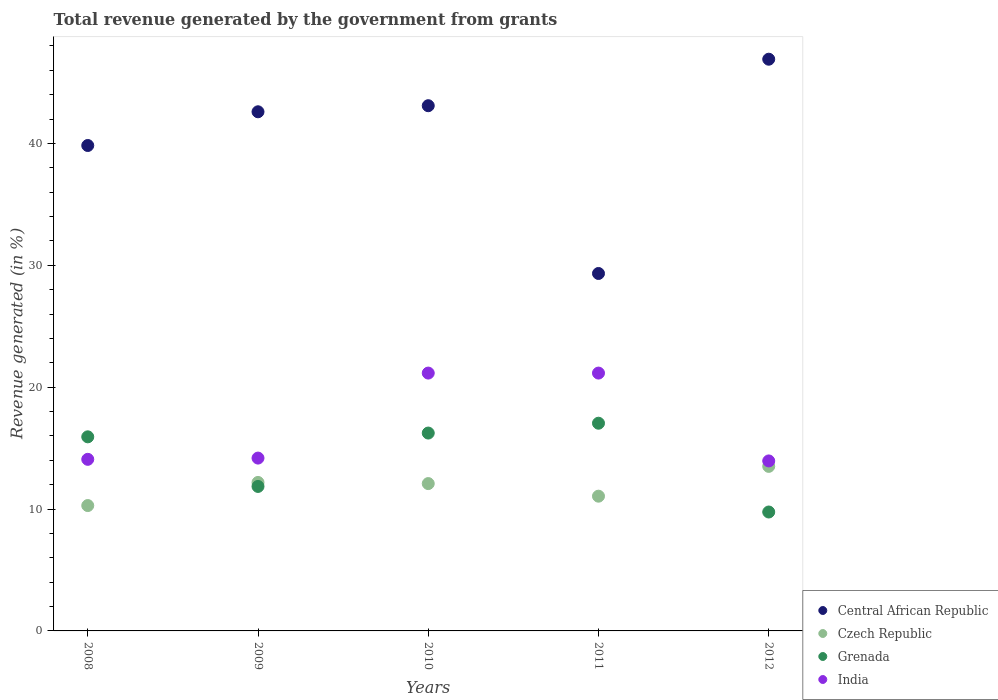How many different coloured dotlines are there?
Your answer should be compact. 4. What is the total revenue generated in India in 2009?
Offer a very short reply. 14.18. Across all years, what is the maximum total revenue generated in India?
Provide a succinct answer. 21.16. Across all years, what is the minimum total revenue generated in India?
Provide a short and direct response. 13.95. In which year was the total revenue generated in Central African Republic maximum?
Offer a terse response. 2012. In which year was the total revenue generated in Central African Republic minimum?
Provide a succinct answer. 2011. What is the total total revenue generated in Grenada in the graph?
Provide a succinct answer. 70.82. What is the difference between the total revenue generated in Czech Republic in 2008 and that in 2010?
Offer a terse response. -1.8. What is the difference between the total revenue generated in Czech Republic in 2008 and the total revenue generated in Central African Republic in 2012?
Offer a terse response. -36.63. What is the average total revenue generated in Grenada per year?
Give a very brief answer. 14.16. In the year 2008, what is the difference between the total revenue generated in Czech Republic and total revenue generated in Grenada?
Offer a terse response. -5.64. What is the ratio of the total revenue generated in Central African Republic in 2011 to that in 2012?
Your response must be concise. 0.63. Is the total revenue generated in Grenada in 2008 less than that in 2010?
Your answer should be compact. Yes. What is the difference between the highest and the lowest total revenue generated in Czech Republic?
Provide a short and direct response. 3.22. Is the sum of the total revenue generated in Central African Republic in 2008 and 2009 greater than the maximum total revenue generated in India across all years?
Your answer should be compact. Yes. Is the total revenue generated in India strictly greater than the total revenue generated in Czech Republic over the years?
Ensure brevity in your answer.  Yes. How many years are there in the graph?
Your answer should be compact. 5. Are the values on the major ticks of Y-axis written in scientific E-notation?
Keep it short and to the point. No. Does the graph contain any zero values?
Ensure brevity in your answer.  No. Does the graph contain grids?
Give a very brief answer. No. Where does the legend appear in the graph?
Provide a short and direct response. Bottom right. What is the title of the graph?
Provide a short and direct response. Total revenue generated by the government from grants. Does "St. Martin (French part)" appear as one of the legend labels in the graph?
Make the answer very short. No. What is the label or title of the Y-axis?
Your answer should be compact. Revenue generated (in %). What is the Revenue generated (in %) in Central African Republic in 2008?
Offer a terse response. 39.83. What is the Revenue generated (in %) of Czech Republic in 2008?
Offer a terse response. 10.29. What is the Revenue generated (in %) of Grenada in 2008?
Ensure brevity in your answer.  15.93. What is the Revenue generated (in %) of India in 2008?
Keep it short and to the point. 14.08. What is the Revenue generated (in %) in Central African Republic in 2009?
Your answer should be compact. 42.6. What is the Revenue generated (in %) of Czech Republic in 2009?
Give a very brief answer. 12.18. What is the Revenue generated (in %) in Grenada in 2009?
Ensure brevity in your answer.  11.86. What is the Revenue generated (in %) of India in 2009?
Give a very brief answer. 14.18. What is the Revenue generated (in %) of Central African Republic in 2010?
Your answer should be very brief. 43.1. What is the Revenue generated (in %) of Czech Republic in 2010?
Keep it short and to the point. 12.09. What is the Revenue generated (in %) of Grenada in 2010?
Your answer should be compact. 16.24. What is the Revenue generated (in %) of India in 2010?
Make the answer very short. 21.16. What is the Revenue generated (in %) in Central African Republic in 2011?
Offer a terse response. 29.33. What is the Revenue generated (in %) of Czech Republic in 2011?
Make the answer very short. 11.06. What is the Revenue generated (in %) in Grenada in 2011?
Offer a very short reply. 17.04. What is the Revenue generated (in %) of India in 2011?
Your answer should be compact. 21.16. What is the Revenue generated (in %) in Central African Republic in 2012?
Your answer should be very brief. 46.91. What is the Revenue generated (in %) of Czech Republic in 2012?
Provide a succinct answer. 13.5. What is the Revenue generated (in %) of Grenada in 2012?
Ensure brevity in your answer.  9.76. What is the Revenue generated (in %) in India in 2012?
Provide a succinct answer. 13.95. Across all years, what is the maximum Revenue generated (in %) in Central African Republic?
Your answer should be very brief. 46.91. Across all years, what is the maximum Revenue generated (in %) in Czech Republic?
Provide a succinct answer. 13.5. Across all years, what is the maximum Revenue generated (in %) in Grenada?
Offer a very short reply. 17.04. Across all years, what is the maximum Revenue generated (in %) in India?
Your answer should be compact. 21.16. Across all years, what is the minimum Revenue generated (in %) in Central African Republic?
Ensure brevity in your answer.  29.33. Across all years, what is the minimum Revenue generated (in %) of Czech Republic?
Offer a very short reply. 10.29. Across all years, what is the minimum Revenue generated (in %) in Grenada?
Your response must be concise. 9.76. Across all years, what is the minimum Revenue generated (in %) of India?
Your answer should be compact. 13.95. What is the total Revenue generated (in %) in Central African Republic in the graph?
Keep it short and to the point. 201.78. What is the total Revenue generated (in %) of Czech Republic in the graph?
Provide a succinct answer. 59.12. What is the total Revenue generated (in %) in Grenada in the graph?
Give a very brief answer. 70.82. What is the total Revenue generated (in %) in India in the graph?
Offer a very short reply. 84.53. What is the difference between the Revenue generated (in %) in Central African Republic in 2008 and that in 2009?
Your response must be concise. -2.77. What is the difference between the Revenue generated (in %) in Czech Republic in 2008 and that in 2009?
Keep it short and to the point. -1.9. What is the difference between the Revenue generated (in %) of Grenada in 2008 and that in 2009?
Provide a succinct answer. 4.07. What is the difference between the Revenue generated (in %) of India in 2008 and that in 2009?
Your answer should be very brief. -0.1. What is the difference between the Revenue generated (in %) of Central African Republic in 2008 and that in 2010?
Your response must be concise. -3.26. What is the difference between the Revenue generated (in %) in Czech Republic in 2008 and that in 2010?
Give a very brief answer. -1.8. What is the difference between the Revenue generated (in %) of Grenada in 2008 and that in 2010?
Offer a terse response. -0.31. What is the difference between the Revenue generated (in %) of India in 2008 and that in 2010?
Your answer should be compact. -7.08. What is the difference between the Revenue generated (in %) in Central African Republic in 2008 and that in 2011?
Make the answer very short. 10.5. What is the difference between the Revenue generated (in %) of Czech Republic in 2008 and that in 2011?
Offer a terse response. -0.77. What is the difference between the Revenue generated (in %) of Grenada in 2008 and that in 2011?
Your response must be concise. -1.12. What is the difference between the Revenue generated (in %) of India in 2008 and that in 2011?
Provide a short and direct response. -7.08. What is the difference between the Revenue generated (in %) of Central African Republic in 2008 and that in 2012?
Ensure brevity in your answer.  -7.08. What is the difference between the Revenue generated (in %) of Czech Republic in 2008 and that in 2012?
Ensure brevity in your answer.  -3.22. What is the difference between the Revenue generated (in %) in Grenada in 2008 and that in 2012?
Give a very brief answer. 6.17. What is the difference between the Revenue generated (in %) of India in 2008 and that in 2012?
Give a very brief answer. 0.13. What is the difference between the Revenue generated (in %) of Central African Republic in 2009 and that in 2010?
Your response must be concise. -0.5. What is the difference between the Revenue generated (in %) of Czech Republic in 2009 and that in 2010?
Your response must be concise. 0.09. What is the difference between the Revenue generated (in %) of Grenada in 2009 and that in 2010?
Ensure brevity in your answer.  -4.38. What is the difference between the Revenue generated (in %) of India in 2009 and that in 2010?
Keep it short and to the point. -6.98. What is the difference between the Revenue generated (in %) of Central African Republic in 2009 and that in 2011?
Your answer should be very brief. 13.27. What is the difference between the Revenue generated (in %) in Czech Republic in 2009 and that in 2011?
Offer a very short reply. 1.13. What is the difference between the Revenue generated (in %) in Grenada in 2009 and that in 2011?
Offer a very short reply. -5.19. What is the difference between the Revenue generated (in %) in India in 2009 and that in 2011?
Provide a short and direct response. -6.98. What is the difference between the Revenue generated (in %) of Central African Republic in 2009 and that in 2012?
Offer a terse response. -4.31. What is the difference between the Revenue generated (in %) of Czech Republic in 2009 and that in 2012?
Offer a very short reply. -1.32. What is the difference between the Revenue generated (in %) in Grenada in 2009 and that in 2012?
Provide a short and direct response. 2.1. What is the difference between the Revenue generated (in %) in India in 2009 and that in 2012?
Your answer should be very brief. 0.23. What is the difference between the Revenue generated (in %) of Central African Republic in 2010 and that in 2011?
Make the answer very short. 13.77. What is the difference between the Revenue generated (in %) in Czech Republic in 2010 and that in 2011?
Your response must be concise. 1.03. What is the difference between the Revenue generated (in %) of Grenada in 2010 and that in 2011?
Make the answer very short. -0.81. What is the difference between the Revenue generated (in %) of Central African Republic in 2010 and that in 2012?
Offer a terse response. -3.82. What is the difference between the Revenue generated (in %) of Czech Republic in 2010 and that in 2012?
Offer a terse response. -1.41. What is the difference between the Revenue generated (in %) in Grenada in 2010 and that in 2012?
Your answer should be compact. 6.48. What is the difference between the Revenue generated (in %) of India in 2010 and that in 2012?
Your response must be concise. 7.21. What is the difference between the Revenue generated (in %) of Central African Republic in 2011 and that in 2012?
Provide a succinct answer. -17.58. What is the difference between the Revenue generated (in %) of Czech Republic in 2011 and that in 2012?
Give a very brief answer. -2.45. What is the difference between the Revenue generated (in %) of Grenada in 2011 and that in 2012?
Give a very brief answer. 7.29. What is the difference between the Revenue generated (in %) of India in 2011 and that in 2012?
Offer a terse response. 7.21. What is the difference between the Revenue generated (in %) in Central African Republic in 2008 and the Revenue generated (in %) in Czech Republic in 2009?
Your answer should be very brief. 27.65. What is the difference between the Revenue generated (in %) of Central African Republic in 2008 and the Revenue generated (in %) of Grenada in 2009?
Offer a very short reply. 27.98. What is the difference between the Revenue generated (in %) of Central African Republic in 2008 and the Revenue generated (in %) of India in 2009?
Keep it short and to the point. 25.65. What is the difference between the Revenue generated (in %) of Czech Republic in 2008 and the Revenue generated (in %) of Grenada in 2009?
Offer a very short reply. -1.57. What is the difference between the Revenue generated (in %) in Czech Republic in 2008 and the Revenue generated (in %) in India in 2009?
Offer a very short reply. -3.9. What is the difference between the Revenue generated (in %) of Grenada in 2008 and the Revenue generated (in %) of India in 2009?
Ensure brevity in your answer.  1.74. What is the difference between the Revenue generated (in %) of Central African Republic in 2008 and the Revenue generated (in %) of Czech Republic in 2010?
Provide a short and direct response. 27.74. What is the difference between the Revenue generated (in %) of Central African Republic in 2008 and the Revenue generated (in %) of Grenada in 2010?
Your response must be concise. 23.6. What is the difference between the Revenue generated (in %) in Central African Republic in 2008 and the Revenue generated (in %) in India in 2010?
Give a very brief answer. 18.68. What is the difference between the Revenue generated (in %) of Czech Republic in 2008 and the Revenue generated (in %) of Grenada in 2010?
Provide a succinct answer. -5.95. What is the difference between the Revenue generated (in %) in Czech Republic in 2008 and the Revenue generated (in %) in India in 2010?
Provide a short and direct response. -10.87. What is the difference between the Revenue generated (in %) of Grenada in 2008 and the Revenue generated (in %) of India in 2010?
Provide a short and direct response. -5.23. What is the difference between the Revenue generated (in %) in Central African Republic in 2008 and the Revenue generated (in %) in Czech Republic in 2011?
Give a very brief answer. 28.78. What is the difference between the Revenue generated (in %) in Central African Republic in 2008 and the Revenue generated (in %) in Grenada in 2011?
Offer a terse response. 22.79. What is the difference between the Revenue generated (in %) in Central African Republic in 2008 and the Revenue generated (in %) in India in 2011?
Give a very brief answer. 18.68. What is the difference between the Revenue generated (in %) of Czech Republic in 2008 and the Revenue generated (in %) of Grenada in 2011?
Offer a very short reply. -6.76. What is the difference between the Revenue generated (in %) in Czech Republic in 2008 and the Revenue generated (in %) in India in 2011?
Provide a succinct answer. -10.87. What is the difference between the Revenue generated (in %) in Grenada in 2008 and the Revenue generated (in %) in India in 2011?
Keep it short and to the point. -5.23. What is the difference between the Revenue generated (in %) in Central African Republic in 2008 and the Revenue generated (in %) in Czech Republic in 2012?
Your answer should be very brief. 26.33. What is the difference between the Revenue generated (in %) of Central African Republic in 2008 and the Revenue generated (in %) of Grenada in 2012?
Ensure brevity in your answer.  30.08. What is the difference between the Revenue generated (in %) in Central African Republic in 2008 and the Revenue generated (in %) in India in 2012?
Ensure brevity in your answer.  25.88. What is the difference between the Revenue generated (in %) in Czech Republic in 2008 and the Revenue generated (in %) in Grenada in 2012?
Keep it short and to the point. 0.53. What is the difference between the Revenue generated (in %) in Czech Republic in 2008 and the Revenue generated (in %) in India in 2012?
Ensure brevity in your answer.  -3.66. What is the difference between the Revenue generated (in %) of Grenada in 2008 and the Revenue generated (in %) of India in 2012?
Make the answer very short. 1.98. What is the difference between the Revenue generated (in %) in Central African Republic in 2009 and the Revenue generated (in %) in Czech Republic in 2010?
Your response must be concise. 30.51. What is the difference between the Revenue generated (in %) in Central African Republic in 2009 and the Revenue generated (in %) in Grenada in 2010?
Your answer should be compact. 26.36. What is the difference between the Revenue generated (in %) of Central African Republic in 2009 and the Revenue generated (in %) of India in 2010?
Your answer should be very brief. 21.44. What is the difference between the Revenue generated (in %) in Czech Republic in 2009 and the Revenue generated (in %) in Grenada in 2010?
Provide a succinct answer. -4.05. What is the difference between the Revenue generated (in %) in Czech Republic in 2009 and the Revenue generated (in %) in India in 2010?
Give a very brief answer. -8.97. What is the difference between the Revenue generated (in %) in Grenada in 2009 and the Revenue generated (in %) in India in 2010?
Ensure brevity in your answer.  -9.3. What is the difference between the Revenue generated (in %) of Central African Republic in 2009 and the Revenue generated (in %) of Czech Republic in 2011?
Offer a very short reply. 31.54. What is the difference between the Revenue generated (in %) of Central African Republic in 2009 and the Revenue generated (in %) of Grenada in 2011?
Your answer should be compact. 25.56. What is the difference between the Revenue generated (in %) of Central African Republic in 2009 and the Revenue generated (in %) of India in 2011?
Provide a short and direct response. 21.44. What is the difference between the Revenue generated (in %) of Czech Republic in 2009 and the Revenue generated (in %) of Grenada in 2011?
Keep it short and to the point. -4.86. What is the difference between the Revenue generated (in %) in Czech Republic in 2009 and the Revenue generated (in %) in India in 2011?
Your response must be concise. -8.97. What is the difference between the Revenue generated (in %) in Grenada in 2009 and the Revenue generated (in %) in India in 2011?
Offer a very short reply. -9.3. What is the difference between the Revenue generated (in %) in Central African Republic in 2009 and the Revenue generated (in %) in Czech Republic in 2012?
Keep it short and to the point. 29.1. What is the difference between the Revenue generated (in %) of Central African Republic in 2009 and the Revenue generated (in %) of Grenada in 2012?
Make the answer very short. 32.84. What is the difference between the Revenue generated (in %) in Central African Republic in 2009 and the Revenue generated (in %) in India in 2012?
Offer a terse response. 28.65. What is the difference between the Revenue generated (in %) in Czech Republic in 2009 and the Revenue generated (in %) in Grenada in 2012?
Ensure brevity in your answer.  2.43. What is the difference between the Revenue generated (in %) in Czech Republic in 2009 and the Revenue generated (in %) in India in 2012?
Provide a short and direct response. -1.77. What is the difference between the Revenue generated (in %) in Grenada in 2009 and the Revenue generated (in %) in India in 2012?
Provide a succinct answer. -2.09. What is the difference between the Revenue generated (in %) of Central African Republic in 2010 and the Revenue generated (in %) of Czech Republic in 2011?
Give a very brief answer. 32.04. What is the difference between the Revenue generated (in %) of Central African Republic in 2010 and the Revenue generated (in %) of Grenada in 2011?
Make the answer very short. 26.05. What is the difference between the Revenue generated (in %) in Central African Republic in 2010 and the Revenue generated (in %) in India in 2011?
Provide a short and direct response. 21.94. What is the difference between the Revenue generated (in %) in Czech Republic in 2010 and the Revenue generated (in %) in Grenada in 2011?
Ensure brevity in your answer.  -4.95. What is the difference between the Revenue generated (in %) of Czech Republic in 2010 and the Revenue generated (in %) of India in 2011?
Offer a very short reply. -9.07. What is the difference between the Revenue generated (in %) in Grenada in 2010 and the Revenue generated (in %) in India in 2011?
Make the answer very short. -4.92. What is the difference between the Revenue generated (in %) of Central African Republic in 2010 and the Revenue generated (in %) of Czech Republic in 2012?
Ensure brevity in your answer.  29.6. What is the difference between the Revenue generated (in %) in Central African Republic in 2010 and the Revenue generated (in %) in Grenada in 2012?
Offer a terse response. 33.34. What is the difference between the Revenue generated (in %) in Central African Republic in 2010 and the Revenue generated (in %) in India in 2012?
Keep it short and to the point. 29.15. What is the difference between the Revenue generated (in %) of Czech Republic in 2010 and the Revenue generated (in %) of Grenada in 2012?
Offer a very short reply. 2.33. What is the difference between the Revenue generated (in %) in Czech Republic in 2010 and the Revenue generated (in %) in India in 2012?
Your answer should be very brief. -1.86. What is the difference between the Revenue generated (in %) in Grenada in 2010 and the Revenue generated (in %) in India in 2012?
Your response must be concise. 2.29. What is the difference between the Revenue generated (in %) in Central African Republic in 2011 and the Revenue generated (in %) in Czech Republic in 2012?
Your answer should be very brief. 15.83. What is the difference between the Revenue generated (in %) in Central African Republic in 2011 and the Revenue generated (in %) in Grenada in 2012?
Your answer should be very brief. 19.57. What is the difference between the Revenue generated (in %) of Central African Republic in 2011 and the Revenue generated (in %) of India in 2012?
Make the answer very short. 15.38. What is the difference between the Revenue generated (in %) in Czech Republic in 2011 and the Revenue generated (in %) in Grenada in 2012?
Make the answer very short. 1.3. What is the difference between the Revenue generated (in %) in Czech Republic in 2011 and the Revenue generated (in %) in India in 2012?
Make the answer very short. -2.89. What is the difference between the Revenue generated (in %) of Grenada in 2011 and the Revenue generated (in %) of India in 2012?
Give a very brief answer. 3.09. What is the average Revenue generated (in %) in Central African Republic per year?
Give a very brief answer. 40.36. What is the average Revenue generated (in %) in Czech Republic per year?
Your response must be concise. 11.82. What is the average Revenue generated (in %) of Grenada per year?
Your response must be concise. 14.16. What is the average Revenue generated (in %) in India per year?
Ensure brevity in your answer.  16.91. In the year 2008, what is the difference between the Revenue generated (in %) of Central African Republic and Revenue generated (in %) of Czech Republic?
Provide a short and direct response. 29.55. In the year 2008, what is the difference between the Revenue generated (in %) of Central African Republic and Revenue generated (in %) of Grenada?
Offer a terse response. 23.91. In the year 2008, what is the difference between the Revenue generated (in %) in Central African Republic and Revenue generated (in %) in India?
Keep it short and to the point. 25.75. In the year 2008, what is the difference between the Revenue generated (in %) of Czech Republic and Revenue generated (in %) of Grenada?
Provide a succinct answer. -5.64. In the year 2008, what is the difference between the Revenue generated (in %) in Czech Republic and Revenue generated (in %) in India?
Ensure brevity in your answer.  -3.79. In the year 2008, what is the difference between the Revenue generated (in %) in Grenada and Revenue generated (in %) in India?
Make the answer very short. 1.85. In the year 2009, what is the difference between the Revenue generated (in %) of Central African Republic and Revenue generated (in %) of Czech Republic?
Your answer should be very brief. 30.42. In the year 2009, what is the difference between the Revenue generated (in %) of Central African Republic and Revenue generated (in %) of Grenada?
Provide a short and direct response. 30.74. In the year 2009, what is the difference between the Revenue generated (in %) of Central African Republic and Revenue generated (in %) of India?
Provide a succinct answer. 28.42. In the year 2009, what is the difference between the Revenue generated (in %) in Czech Republic and Revenue generated (in %) in Grenada?
Provide a succinct answer. 0.33. In the year 2009, what is the difference between the Revenue generated (in %) of Czech Republic and Revenue generated (in %) of India?
Offer a terse response. -2. In the year 2009, what is the difference between the Revenue generated (in %) of Grenada and Revenue generated (in %) of India?
Provide a short and direct response. -2.33. In the year 2010, what is the difference between the Revenue generated (in %) in Central African Republic and Revenue generated (in %) in Czech Republic?
Your answer should be very brief. 31.01. In the year 2010, what is the difference between the Revenue generated (in %) of Central African Republic and Revenue generated (in %) of Grenada?
Keep it short and to the point. 26.86. In the year 2010, what is the difference between the Revenue generated (in %) of Central African Republic and Revenue generated (in %) of India?
Ensure brevity in your answer.  21.94. In the year 2010, what is the difference between the Revenue generated (in %) of Czech Republic and Revenue generated (in %) of Grenada?
Provide a short and direct response. -4.15. In the year 2010, what is the difference between the Revenue generated (in %) in Czech Republic and Revenue generated (in %) in India?
Provide a succinct answer. -9.07. In the year 2010, what is the difference between the Revenue generated (in %) in Grenada and Revenue generated (in %) in India?
Offer a very short reply. -4.92. In the year 2011, what is the difference between the Revenue generated (in %) in Central African Republic and Revenue generated (in %) in Czech Republic?
Provide a succinct answer. 18.27. In the year 2011, what is the difference between the Revenue generated (in %) of Central African Republic and Revenue generated (in %) of Grenada?
Offer a terse response. 12.29. In the year 2011, what is the difference between the Revenue generated (in %) of Central African Republic and Revenue generated (in %) of India?
Your answer should be very brief. 8.17. In the year 2011, what is the difference between the Revenue generated (in %) of Czech Republic and Revenue generated (in %) of Grenada?
Your answer should be compact. -5.99. In the year 2011, what is the difference between the Revenue generated (in %) in Czech Republic and Revenue generated (in %) in India?
Give a very brief answer. -10.1. In the year 2011, what is the difference between the Revenue generated (in %) of Grenada and Revenue generated (in %) of India?
Provide a succinct answer. -4.11. In the year 2012, what is the difference between the Revenue generated (in %) of Central African Republic and Revenue generated (in %) of Czech Republic?
Your response must be concise. 33.41. In the year 2012, what is the difference between the Revenue generated (in %) in Central African Republic and Revenue generated (in %) in Grenada?
Offer a terse response. 37.16. In the year 2012, what is the difference between the Revenue generated (in %) of Central African Republic and Revenue generated (in %) of India?
Provide a succinct answer. 32.96. In the year 2012, what is the difference between the Revenue generated (in %) in Czech Republic and Revenue generated (in %) in Grenada?
Offer a terse response. 3.74. In the year 2012, what is the difference between the Revenue generated (in %) of Czech Republic and Revenue generated (in %) of India?
Provide a short and direct response. -0.45. In the year 2012, what is the difference between the Revenue generated (in %) of Grenada and Revenue generated (in %) of India?
Offer a terse response. -4.19. What is the ratio of the Revenue generated (in %) of Central African Republic in 2008 to that in 2009?
Your answer should be compact. 0.94. What is the ratio of the Revenue generated (in %) in Czech Republic in 2008 to that in 2009?
Offer a terse response. 0.84. What is the ratio of the Revenue generated (in %) in Grenada in 2008 to that in 2009?
Make the answer very short. 1.34. What is the ratio of the Revenue generated (in %) of India in 2008 to that in 2009?
Provide a short and direct response. 0.99. What is the ratio of the Revenue generated (in %) in Central African Republic in 2008 to that in 2010?
Give a very brief answer. 0.92. What is the ratio of the Revenue generated (in %) of Czech Republic in 2008 to that in 2010?
Offer a terse response. 0.85. What is the ratio of the Revenue generated (in %) of Grenada in 2008 to that in 2010?
Keep it short and to the point. 0.98. What is the ratio of the Revenue generated (in %) in India in 2008 to that in 2010?
Provide a succinct answer. 0.67. What is the ratio of the Revenue generated (in %) in Central African Republic in 2008 to that in 2011?
Your answer should be compact. 1.36. What is the ratio of the Revenue generated (in %) in Czech Republic in 2008 to that in 2011?
Offer a very short reply. 0.93. What is the ratio of the Revenue generated (in %) in Grenada in 2008 to that in 2011?
Your answer should be very brief. 0.93. What is the ratio of the Revenue generated (in %) of India in 2008 to that in 2011?
Offer a very short reply. 0.67. What is the ratio of the Revenue generated (in %) of Central African Republic in 2008 to that in 2012?
Make the answer very short. 0.85. What is the ratio of the Revenue generated (in %) in Czech Republic in 2008 to that in 2012?
Give a very brief answer. 0.76. What is the ratio of the Revenue generated (in %) in Grenada in 2008 to that in 2012?
Give a very brief answer. 1.63. What is the ratio of the Revenue generated (in %) in India in 2008 to that in 2012?
Your answer should be very brief. 1.01. What is the ratio of the Revenue generated (in %) in Central African Republic in 2009 to that in 2010?
Your answer should be very brief. 0.99. What is the ratio of the Revenue generated (in %) of Czech Republic in 2009 to that in 2010?
Your answer should be very brief. 1.01. What is the ratio of the Revenue generated (in %) in Grenada in 2009 to that in 2010?
Give a very brief answer. 0.73. What is the ratio of the Revenue generated (in %) in India in 2009 to that in 2010?
Offer a very short reply. 0.67. What is the ratio of the Revenue generated (in %) in Central African Republic in 2009 to that in 2011?
Ensure brevity in your answer.  1.45. What is the ratio of the Revenue generated (in %) in Czech Republic in 2009 to that in 2011?
Give a very brief answer. 1.1. What is the ratio of the Revenue generated (in %) in Grenada in 2009 to that in 2011?
Ensure brevity in your answer.  0.7. What is the ratio of the Revenue generated (in %) in India in 2009 to that in 2011?
Keep it short and to the point. 0.67. What is the ratio of the Revenue generated (in %) in Central African Republic in 2009 to that in 2012?
Keep it short and to the point. 0.91. What is the ratio of the Revenue generated (in %) of Czech Republic in 2009 to that in 2012?
Offer a very short reply. 0.9. What is the ratio of the Revenue generated (in %) of Grenada in 2009 to that in 2012?
Offer a terse response. 1.22. What is the ratio of the Revenue generated (in %) in India in 2009 to that in 2012?
Make the answer very short. 1.02. What is the ratio of the Revenue generated (in %) of Central African Republic in 2010 to that in 2011?
Provide a succinct answer. 1.47. What is the ratio of the Revenue generated (in %) of Czech Republic in 2010 to that in 2011?
Provide a short and direct response. 1.09. What is the ratio of the Revenue generated (in %) of Grenada in 2010 to that in 2011?
Your response must be concise. 0.95. What is the ratio of the Revenue generated (in %) of Central African Republic in 2010 to that in 2012?
Your answer should be very brief. 0.92. What is the ratio of the Revenue generated (in %) in Czech Republic in 2010 to that in 2012?
Keep it short and to the point. 0.9. What is the ratio of the Revenue generated (in %) in Grenada in 2010 to that in 2012?
Provide a short and direct response. 1.66. What is the ratio of the Revenue generated (in %) of India in 2010 to that in 2012?
Your response must be concise. 1.52. What is the ratio of the Revenue generated (in %) in Central African Republic in 2011 to that in 2012?
Offer a terse response. 0.63. What is the ratio of the Revenue generated (in %) of Czech Republic in 2011 to that in 2012?
Provide a short and direct response. 0.82. What is the ratio of the Revenue generated (in %) of Grenada in 2011 to that in 2012?
Offer a terse response. 1.75. What is the ratio of the Revenue generated (in %) in India in 2011 to that in 2012?
Your answer should be very brief. 1.52. What is the difference between the highest and the second highest Revenue generated (in %) in Central African Republic?
Make the answer very short. 3.82. What is the difference between the highest and the second highest Revenue generated (in %) of Czech Republic?
Ensure brevity in your answer.  1.32. What is the difference between the highest and the second highest Revenue generated (in %) of Grenada?
Your answer should be very brief. 0.81. What is the difference between the highest and the second highest Revenue generated (in %) in India?
Your response must be concise. 0. What is the difference between the highest and the lowest Revenue generated (in %) of Central African Republic?
Keep it short and to the point. 17.58. What is the difference between the highest and the lowest Revenue generated (in %) of Czech Republic?
Ensure brevity in your answer.  3.22. What is the difference between the highest and the lowest Revenue generated (in %) of Grenada?
Provide a short and direct response. 7.29. What is the difference between the highest and the lowest Revenue generated (in %) of India?
Provide a short and direct response. 7.21. 